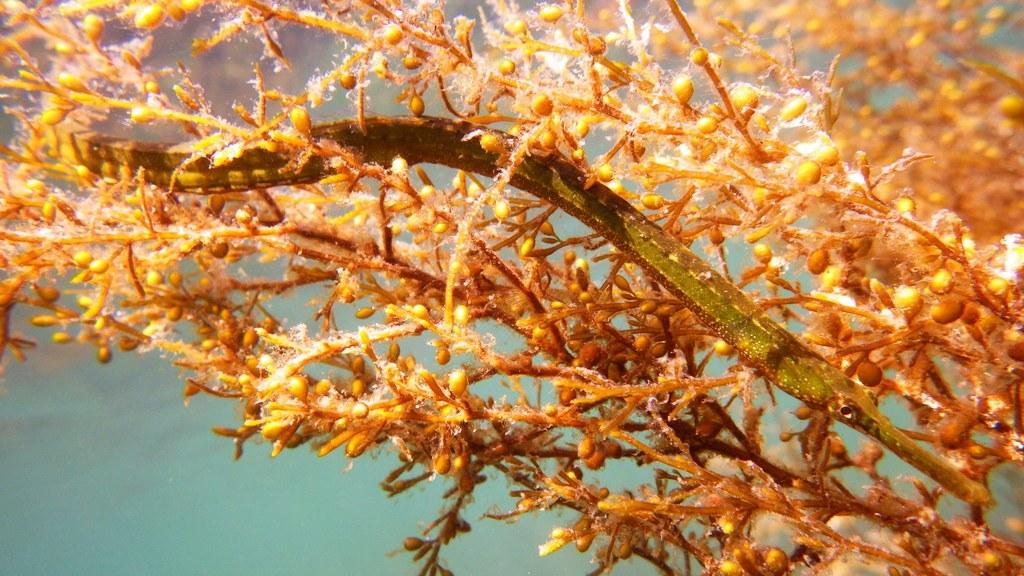What can be seen in the image that resembles plant parts? There are stems in the image. What color is the background of the image? The background of the image is green. What type of apparel is being worn by the spy in the image? There is no spy or apparel present in the image; it only features stems and a green background. 